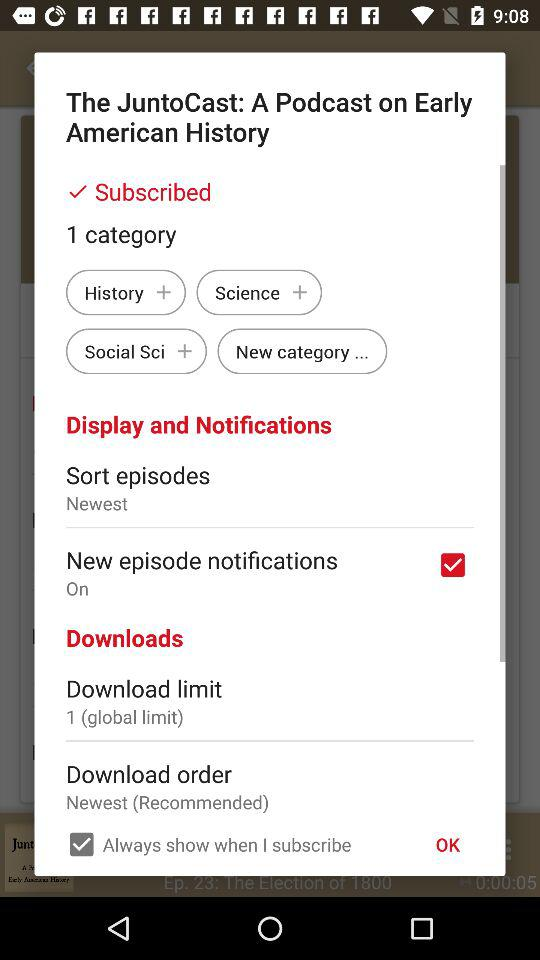How many download limits are there? The download limit is 1. 